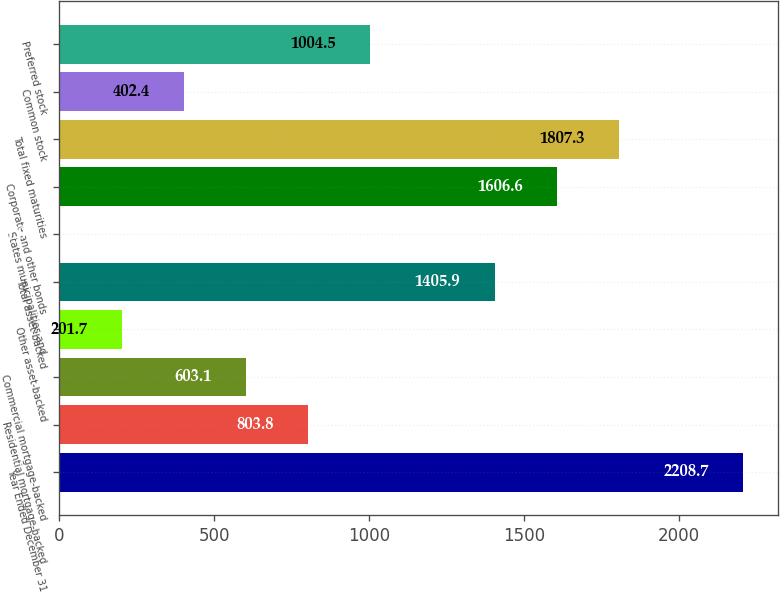Convert chart. <chart><loc_0><loc_0><loc_500><loc_500><bar_chart><fcel>Year Ended December 31<fcel>Residential mortgage-backed<fcel>Commercial mortgage-backed<fcel>Other asset-backed<fcel>Total asset-backed<fcel>States municipalities and<fcel>Corporate and other bonds<fcel>Total fixed maturities<fcel>Common stock<fcel>Preferred stock<nl><fcel>2208.7<fcel>803.8<fcel>603.1<fcel>201.7<fcel>1405.9<fcel>1<fcel>1606.6<fcel>1807.3<fcel>402.4<fcel>1004.5<nl></chart> 